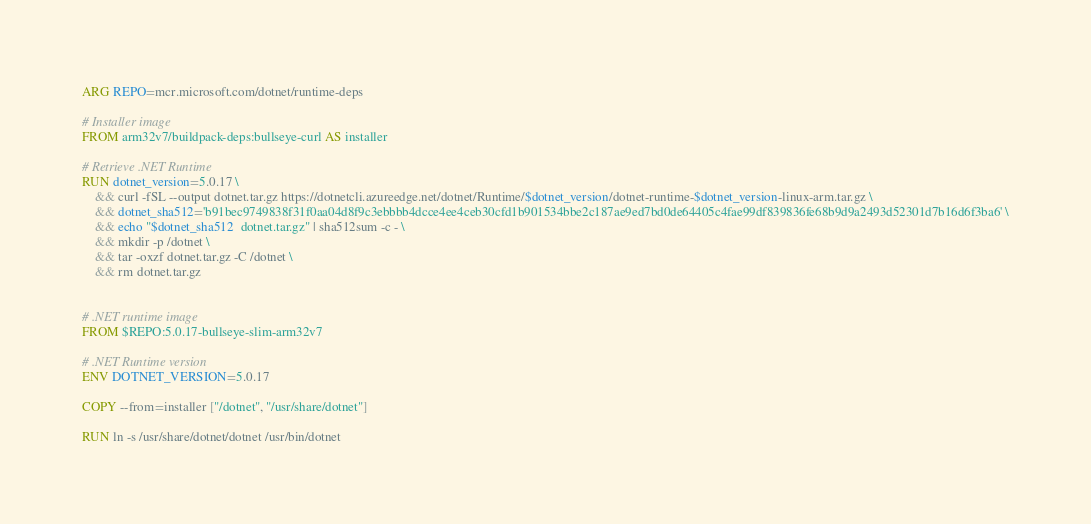<code> <loc_0><loc_0><loc_500><loc_500><_Dockerfile_>ARG REPO=mcr.microsoft.com/dotnet/runtime-deps

# Installer image
FROM arm32v7/buildpack-deps:bullseye-curl AS installer

# Retrieve .NET Runtime
RUN dotnet_version=5.0.17 \
    && curl -fSL --output dotnet.tar.gz https://dotnetcli.azureedge.net/dotnet/Runtime/$dotnet_version/dotnet-runtime-$dotnet_version-linux-arm.tar.gz \
    && dotnet_sha512='b91bec9749838f31f0aa04d8f9c3ebbbb4dcce4ee4ceb30cfd1b901534bbe2c187ae9ed7bd0de64405c4fae99df839836fe68b9d9a2493d52301d7b16d6f3ba6' \
    && echo "$dotnet_sha512  dotnet.tar.gz" | sha512sum -c - \
    && mkdir -p /dotnet \
    && tar -oxzf dotnet.tar.gz -C /dotnet \
    && rm dotnet.tar.gz


# .NET runtime image
FROM $REPO:5.0.17-bullseye-slim-arm32v7

# .NET Runtime version
ENV DOTNET_VERSION=5.0.17

COPY --from=installer ["/dotnet", "/usr/share/dotnet"]

RUN ln -s /usr/share/dotnet/dotnet /usr/bin/dotnet
</code> 